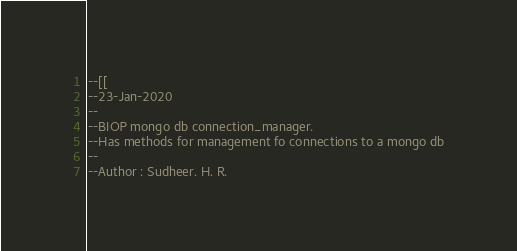Convert code to text. <code><loc_0><loc_0><loc_500><loc_500><_Lua_>--[[
--23-Jan-2020
--
--BIOP mongo db connection_manager.
--Has methods for management fo connections to a mongo db
--
--Author : Sudheer. H. R.</code> 